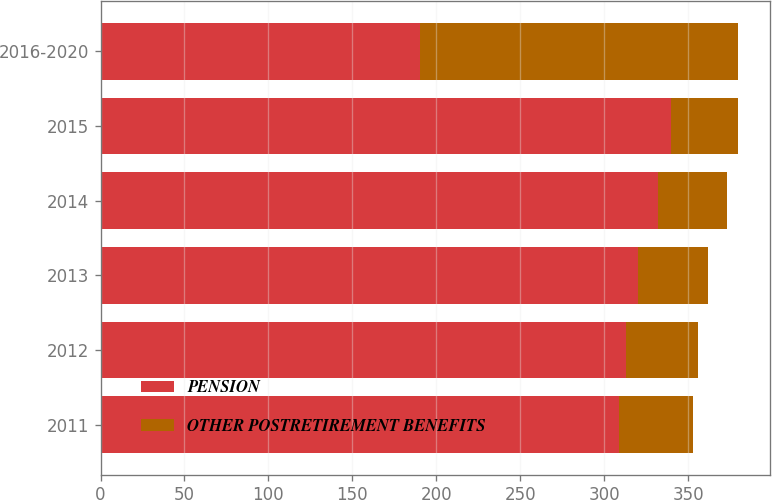<chart> <loc_0><loc_0><loc_500><loc_500><stacked_bar_chart><ecel><fcel>2011<fcel>2012<fcel>2013<fcel>2014<fcel>2015<fcel>2016-2020<nl><fcel>PENSION<fcel>309<fcel>313<fcel>320<fcel>332<fcel>340<fcel>190<nl><fcel>OTHER POSTRETIREMENT BENEFITS<fcel>44<fcel>43<fcel>42<fcel>41<fcel>40<fcel>190<nl></chart> 